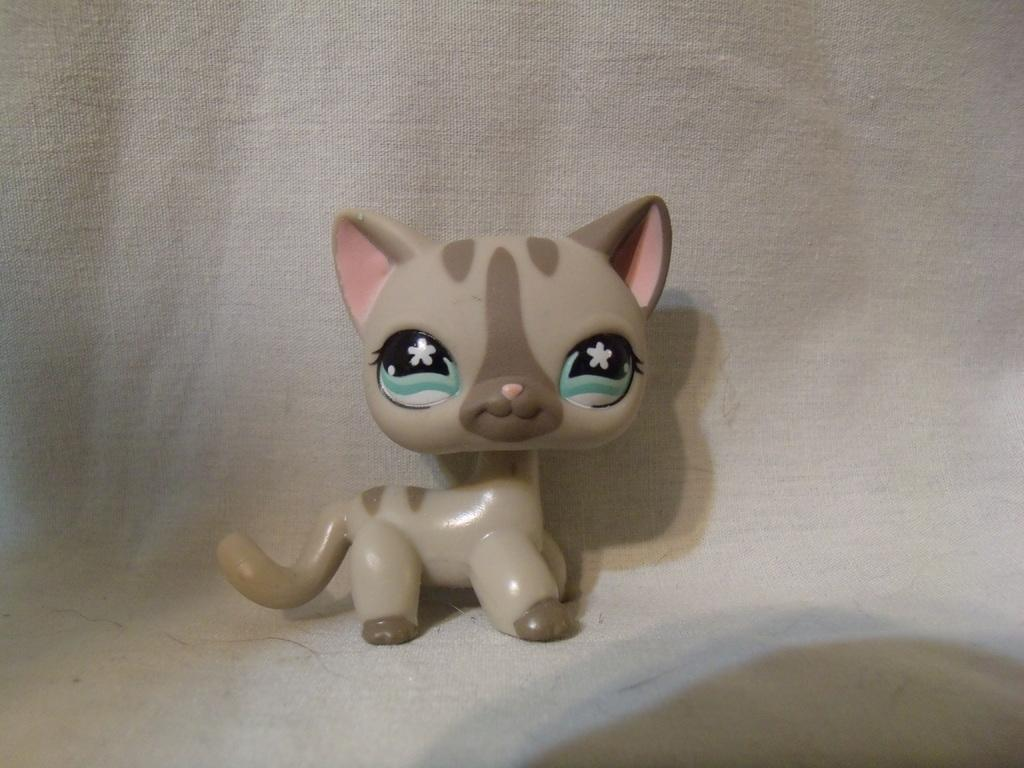What is the main subject in the center of the image? There is a toy of a cat in the center of the image. What color is the object in the background of the image? There is a white color object in the background of the image. What type of guitar is being played in the image? There is no guitar present in the image. How many people are playing with the rake in the image? There is no rake or indication of any play activity in the image. 